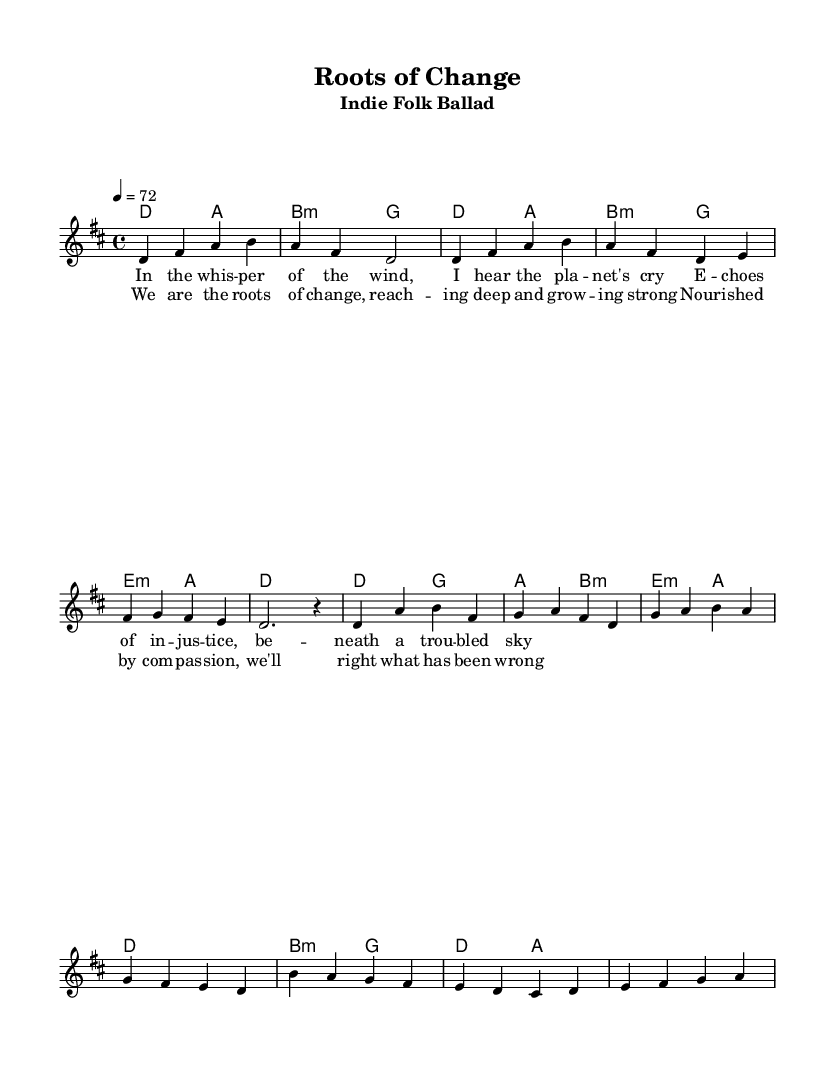What is the key signature of this music? The key signature is indicated at the beginning of the score, which shows two sharps, corresponding to D major.
Answer: D major What is the time signature of this piece? The time signature is located at the beginning of the score, represented by 4/4, meaning there are four beats in each measure.
Answer: 4/4 What is the tempo marking for this piece? The tempo marking is specified in the beginning section of the score, stating 4 equals 72, which indicates the beat speed.
Answer: 72 How many sections does the piece have? By analyzing the structure of the sheet music, there are four distinct sections: Intro, Verse, Chorus, and Bridge.
Answer: Four What is the mood of the song as suggested by the lyrics and melody? The title and lyrics focus on "roots of change" and themes of social justice, suggesting a reflective and hopeful mood.
Answer: Reflective and hopeful In which measure does the chorus begin? By counting the measures from the start of the score, the chorus starts at measure 5.
Answer: Measure 5 What is the chord progression in the verse? The chord progression in the verse can be traced through the corresponding harmonies beneath the melody, which is D major to A major, then B minor to G major, and so forth.
Answer: D, A, B minor, G 